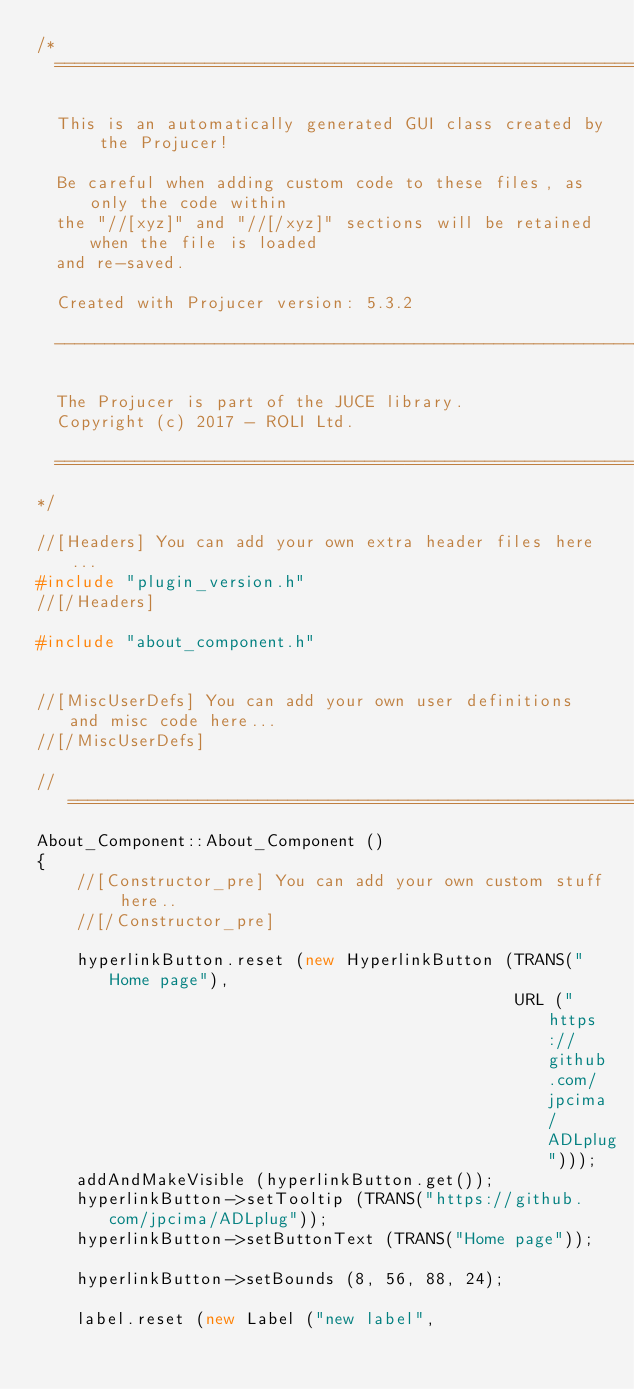Convert code to text. <code><loc_0><loc_0><loc_500><loc_500><_C++_>/*
  ==============================================================================

  This is an automatically generated GUI class created by the Projucer!

  Be careful when adding custom code to these files, as only the code within
  the "//[xyz]" and "//[/xyz]" sections will be retained when the file is loaded
  and re-saved.

  Created with Projucer version: 5.3.2

  ------------------------------------------------------------------------------

  The Projucer is part of the JUCE library.
  Copyright (c) 2017 - ROLI Ltd.

  ==============================================================================
*/

//[Headers] You can add your own extra header files here...
#include "plugin_version.h"
//[/Headers]

#include "about_component.h"


//[MiscUserDefs] You can add your own user definitions and misc code here...
//[/MiscUserDefs]

//==============================================================================
About_Component::About_Component ()
{
    //[Constructor_pre] You can add your own custom stuff here..
    //[/Constructor_pre]

    hyperlinkButton.reset (new HyperlinkButton (TRANS("Home page"),
                                                URL ("https://github.com/jpcima/ADLplug")));
    addAndMakeVisible (hyperlinkButton.get());
    hyperlinkButton->setTooltip (TRANS("https://github.com/jpcima/ADLplug"));
    hyperlinkButton->setButtonText (TRANS("Home page"));

    hyperlinkButton->setBounds (8, 56, 88, 24);

    label.reset (new Label ("new label",</code> 